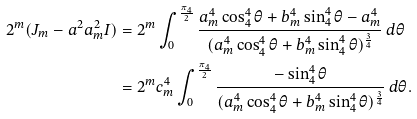Convert formula to latex. <formula><loc_0><loc_0><loc_500><loc_500>2 ^ { m } ( J _ { m } - a ^ { 2 } a _ { m } ^ { 2 } I ) & = 2 ^ { m } \int _ { 0 } ^ { \frac { \pi _ { 4 } } { 2 } } \frac { a _ { m } ^ { 4 } \cos _ { 4 } ^ { 4 } { \theta } + b _ { m } ^ { 4 } \sin _ { 4 } ^ { 4 } { \theta } - a _ { m } ^ { 4 } } { ( a _ { m } ^ { 4 } \cos _ { 4 } ^ { 4 } { \theta } + b _ { m } ^ { 4 } \sin _ { 4 } ^ { 4 } { \theta } ) ^ { \frac { 3 } { 4 } } } \, d \theta \\ & = 2 ^ { m } c _ { m } ^ { 4 } \int _ { 0 } ^ { \frac { \pi _ { 4 } } { 2 } } \frac { - \sin _ { 4 } ^ { 4 } { \theta } } { ( a _ { m } ^ { 4 } \cos _ { 4 } ^ { 4 } { \theta } + b _ { m } ^ { 4 } \sin _ { 4 } ^ { 4 } { \theta } ) ^ { \frac { 3 } { 4 } } } \, d \theta .</formula> 